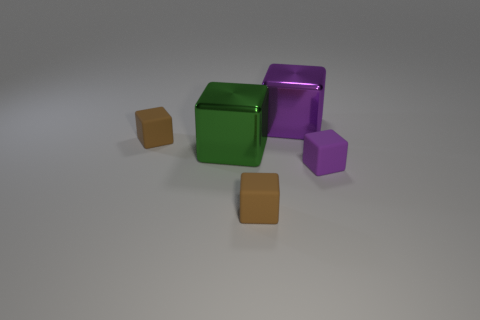Subtract all tiny brown cubes. How many cubes are left? 3 Subtract all green blocks. How many blocks are left? 4 Subtract all small rubber objects. Subtract all big green shiny objects. How many objects are left? 1 Add 5 brown cubes. How many brown cubes are left? 7 Add 3 small yellow balls. How many small yellow balls exist? 3 Add 2 purple shiny cubes. How many objects exist? 7 Subtract 0 purple spheres. How many objects are left? 5 Subtract 5 blocks. How many blocks are left? 0 Subtract all blue blocks. Subtract all gray balls. How many blocks are left? 5 Subtract all brown cylinders. How many red blocks are left? 0 